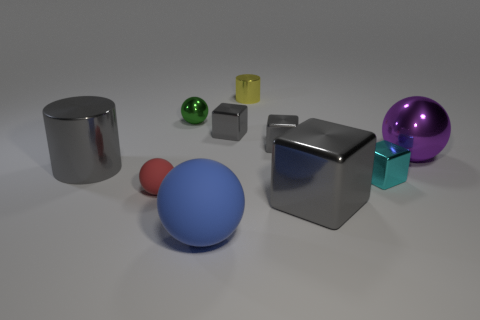How many gray cubes must be subtracted to get 2 gray cubes? 1 Subtract all gray cylinders. How many gray cubes are left? 3 Subtract all spheres. How many objects are left? 6 Subtract all red rubber cylinders. Subtract all yellow metallic objects. How many objects are left? 9 Add 2 small green shiny balls. How many small green shiny balls are left? 3 Add 3 small green cylinders. How many small green cylinders exist? 3 Subtract 1 blue spheres. How many objects are left? 9 